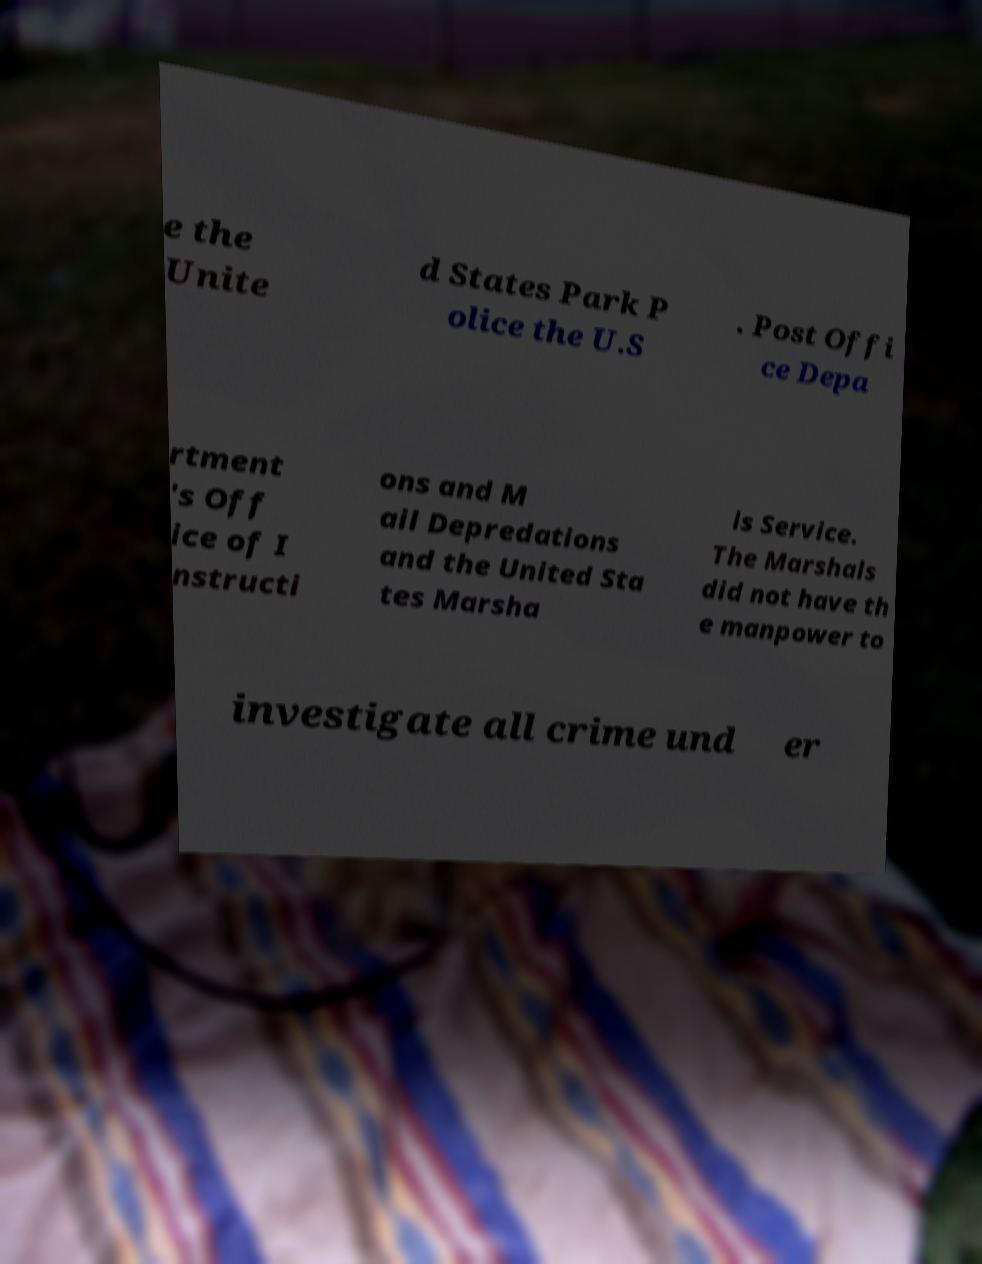What messages or text are displayed in this image? I need them in a readable, typed format. e the Unite d States Park P olice the U.S . Post Offi ce Depa rtment 's Off ice of I nstructi ons and M ail Depredations and the United Sta tes Marsha ls Service. The Marshals did not have th e manpower to investigate all crime und er 